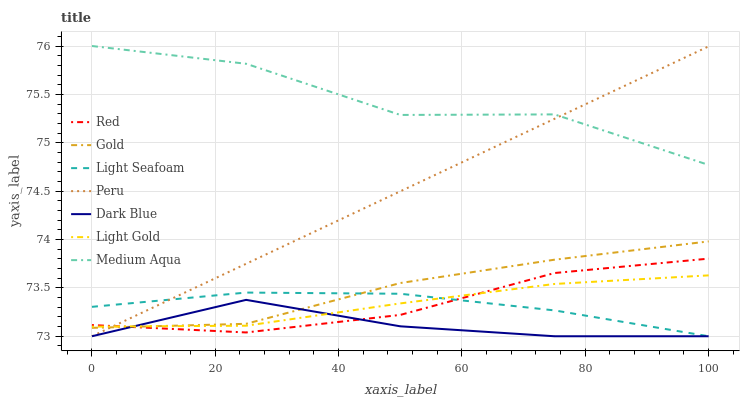Does Dark Blue have the minimum area under the curve?
Answer yes or no. Yes. Does Medium Aqua have the maximum area under the curve?
Answer yes or no. Yes. Does Medium Aqua have the minimum area under the curve?
Answer yes or no. No. Does Dark Blue have the maximum area under the curve?
Answer yes or no. No. Is Peru the smoothest?
Answer yes or no. Yes. Is Medium Aqua the roughest?
Answer yes or no. Yes. Is Dark Blue the smoothest?
Answer yes or no. No. Is Dark Blue the roughest?
Answer yes or no. No. Does Dark Blue have the lowest value?
Answer yes or no. Yes. Does Medium Aqua have the lowest value?
Answer yes or no. No. Does Medium Aqua have the highest value?
Answer yes or no. Yes. Does Dark Blue have the highest value?
Answer yes or no. No. Is Gold less than Medium Aqua?
Answer yes or no. Yes. Is Medium Aqua greater than Light Seafoam?
Answer yes or no. Yes. Does Dark Blue intersect Light Seafoam?
Answer yes or no. Yes. Is Dark Blue less than Light Seafoam?
Answer yes or no. No. Is Dark Blue greater than Light Seafoam?
Answer yes or no. No. Does Gold intersect Medium Aqua?
Answer yes or no. No. 